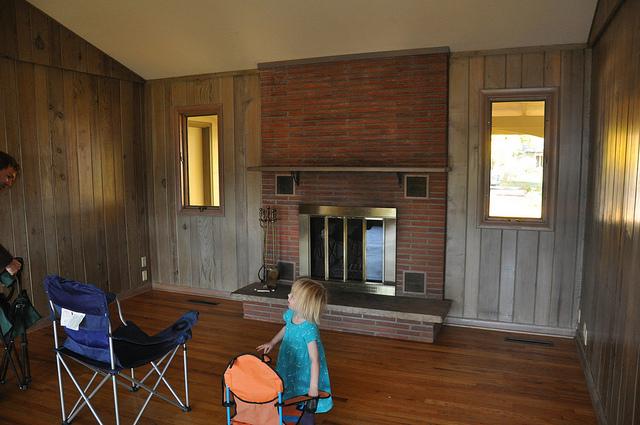Is the room tidy?
Keep it brief. Yes. What color is the little girls dress?
Concise answer only. Blue. What animals are in the picture?
Write a very short answer. None. Is it daylight outside the window?
Write a very short answer. Yes. Are the chairs antique?
Quick response, please. No. 